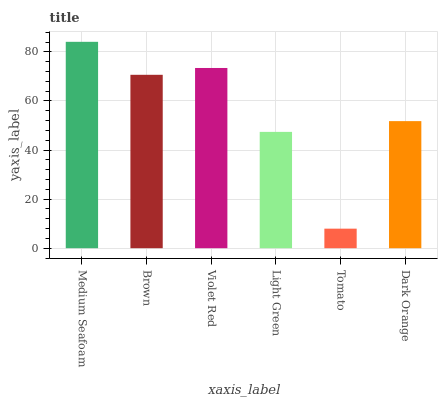Is Brown the minimum?
Answer yes or no. No. Is Brown the maximum?
Answer yes or no. No. Is Medium Seafoam greater than Brown?
Answer yes or no. Yes. Is Brown less than Medium Seafoam?
Answer yes or no. Yes. Is Brown greater than Medium Seafoam?
Answer yes or no. No. Is Medium Seafoam less than Brown?
Answer yes or no. No. Is Brown the high median?
Answer yes or no. Yes. Is Dark Orange the low median?
Answer yes or no. Yes. Is Light Green the high median?
Answer yes or no. No. Is Light Green the low median?
Answer yes or no. No. 